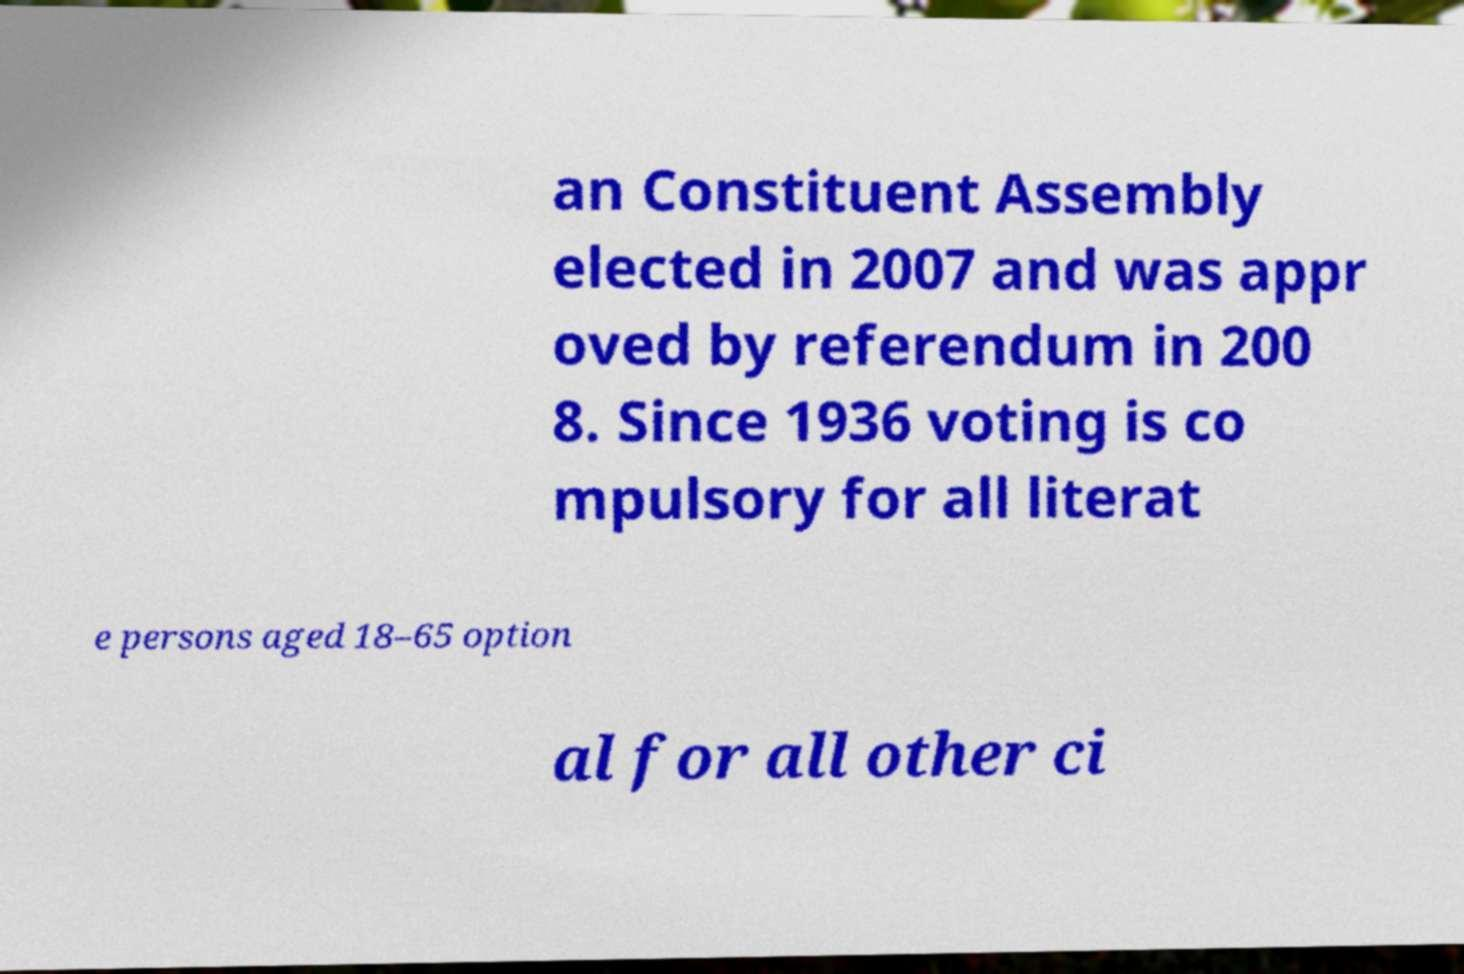For documentation purposes, I need the text within this image transcribed. Could you provide that? an Constituent Assembly elected in 2007 and was appr oved by referendum in 200 8. Since 1936 voting is co mpulsory for all literat e persons aged 18–65 option al for all other ci 